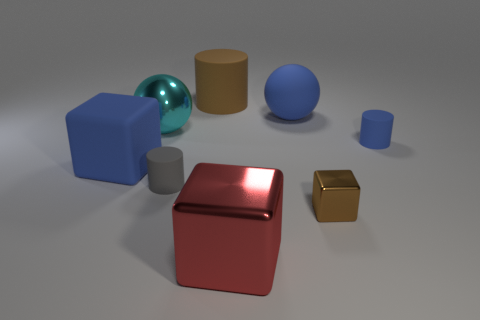Subtract all blue rubber blocks. How many blocks are left? 2 Subtract all brown cubes. How many cubes are left? 2 Add 2 brown rubber spheres. How many objects exist? 10 Subtract all balls. How many objects are left? 6 Subtract 2 cylinders. How many cylinders are left? 1 Add 6 cylinders. How many cylinders exist? 9 Subtract 1 gray cylinders. How many objects are left? 7 Subtract all cyan spheres. Subtract all brown cylinders. How many spheres are left? 1 Subtract all big metal spheres. Subtract all metallic spheres. How many objects are left? 6 Add 7 cyan objects. How many cyan objects are left? 8 